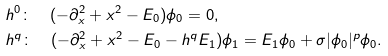<formula> <loc_0><loc_0><loc_500><loc_500>& h ^ { 0 } \colon \quad ( - \partial _ { x } ^ { 2 } + x ^ { 2 } - E _ { 0 } ) \phi _ { 0 } = 0 , \\ & h ^ { q } \colon \quad ( - \partial _ { x } ^ { 2 } + x ^ { 2 } - E _ { 0 } - h ^ { q } E _ { 1 } ) \phi _ { 1 } = E _ { 1 } \phi _ { 0 } + \sigma | \phi _ { 0 } | ^ { p } \phi _ { 0 } .</formula> 